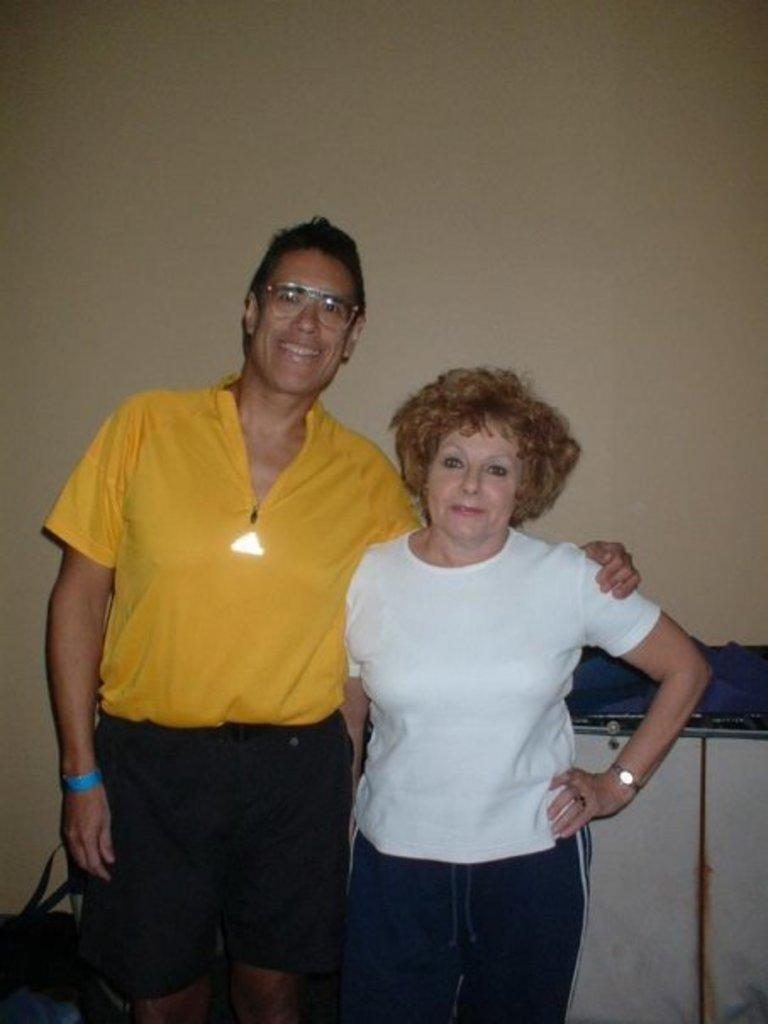How many people are in the image? There are two people in the image, a man and a woman. What are the man and woman doing in the image? The man and woman are standing in the middle of the image and smiling. What can be seen in the background of the image? There is a wall in the background of the image. Can you see any goats or boats in the image? No, there are no goats or boats present in the image. Are the man and woman swimming in the image? No, the man and woman are standing, not swimming, in the image. 